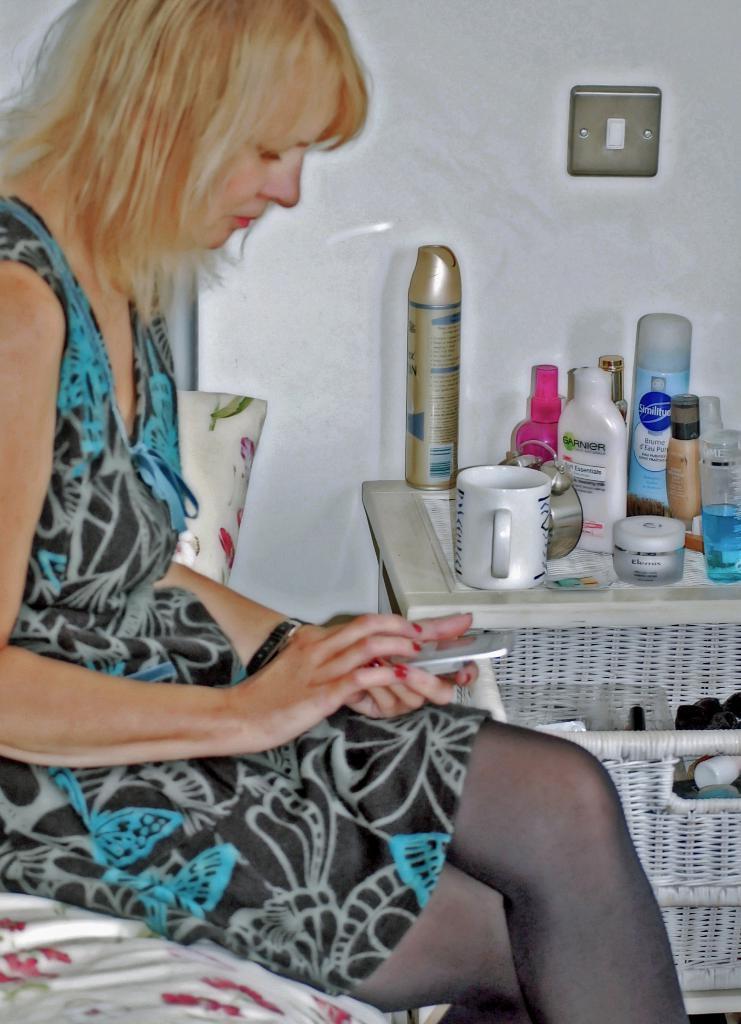How would you summarize this image in a sentence or two? In this picture, we see the woman in the black and blue dress is sitting on the bed. She is holding the mobile phone in her hands. Beside her, we see a table on which lotion bottles and some creams are placed. In the bottom right, we see a basket containing some objects. In the background, we see a white wall. This might be an edited image. 